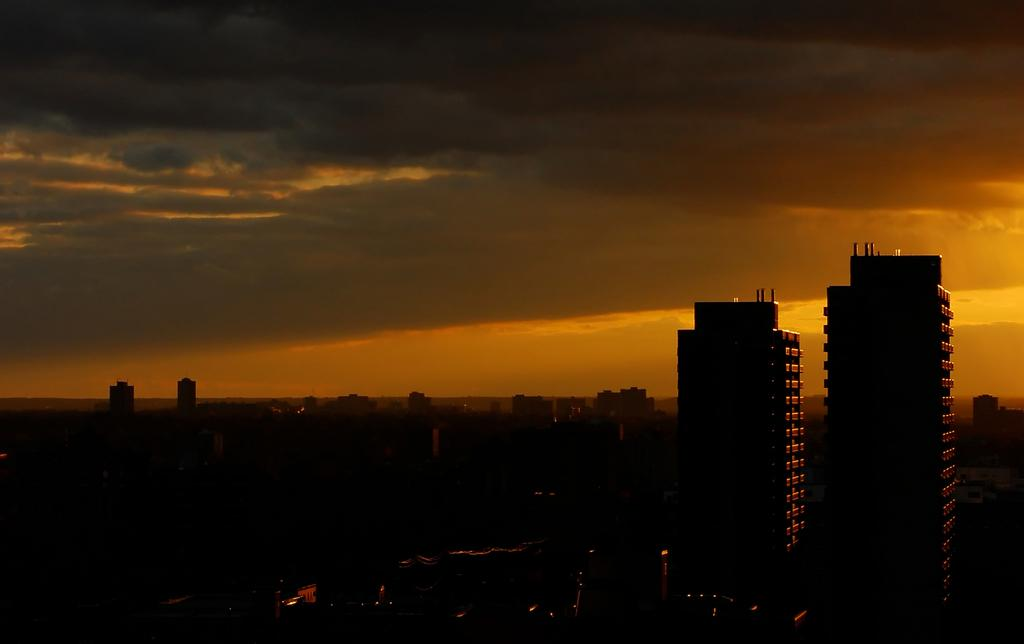What type of structures can be seen in the image? There are buildings in the image. What can be seen illuminating the scene in the image? There are lights visible in the image. What is visible in the background of the image? The sky is visible in the background of the image. What can be observed in the sky in the image? There are clouds in the sky. What type of bead is being used to decorate the buildings in the image? There is no bead present in the image, and therefore no such decoration can be observed. Can you tell me how many horns are visible on the buildings in the image? There are no horns present on the buildings in the image. 